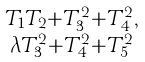<formula> <loc_0><loc_0><loc_500><loc_500>\begin{smallmatrix} T _ { 1 } T _ { 2 } + T _ { 3 } ^ { 2 } + T _ { 4 } ^ { 2 } , \\ \lambda T _ { 3 } ^ { 2 } + T _ { 4 } ^ { 2 } + T _ { 5 } ^ { 2 } \end{smallmatrix}</formula> 